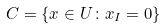<formula> <loc_0><loc_0><loc_500><loc_500>C = \{ x \in U \colon x _ { I } = 0 \}</formula> 